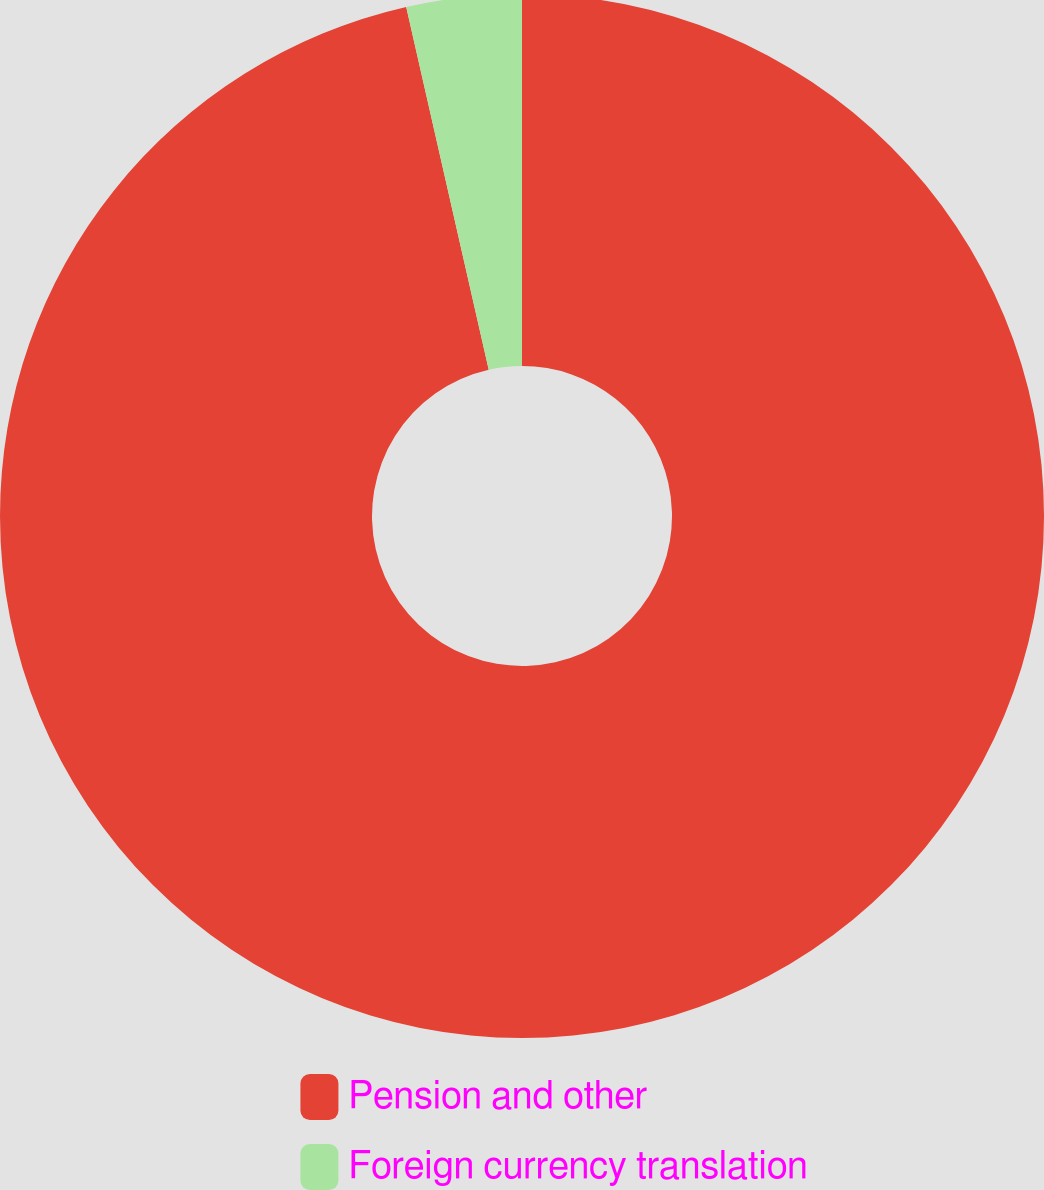Convert chart to OTSL. <chart><loc_0><loc_0><loc_500><loc_500><pie_chart><fcel>Pension and other<fcel>Foreign currency translation<nl><fcel>96.44%<fcel>3.56%<nl></chart> 